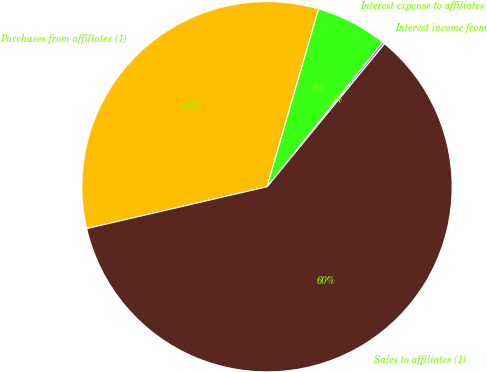Convert chart to OTSL. <chart><loc_0><loc_0><loc_500><loc_500><pie_chart><fcel>Purchases from affiliates (1)<fcel>Sales to affiliates (1)<fcel>Interest income from<fcel>Interest expense to affiliates<nl><fcel>33.13%<fcel>60.43%<fcel>0.21%<fcel>6.23%<nl></chart> 